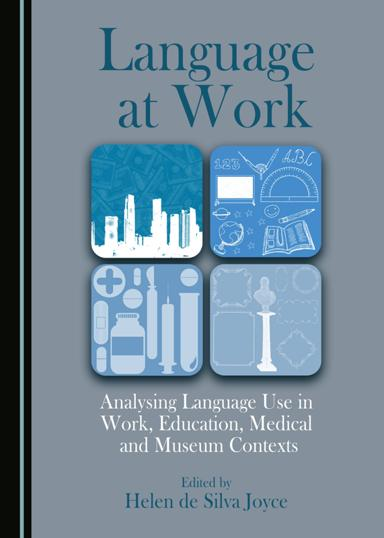Can you describe the cover design of "Language at Work" and interpret its elements? The cover of "Language at Work" features a serene blue palette with grid-like icons representing various themes: a cityscape, medical symbols, educational tools, and museum artifacts. These icons symbolize the different contexts where language analysis is applied, effectively conveying the book's scope on analyzing language use across diverse environments. 